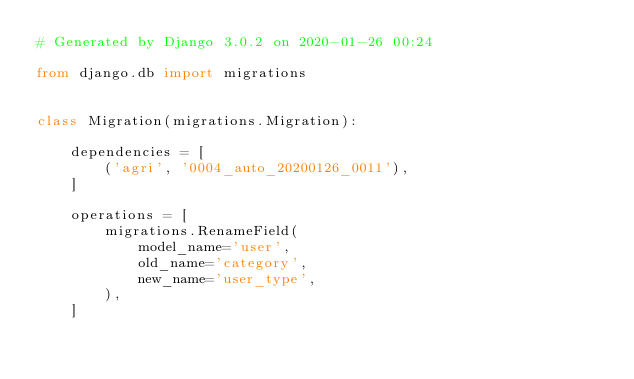Convert code to text. <code><loc_0><loc_0><loc_500><loc_500><_Python_># Generated by Django 3.0.2 on 2020-01-26 00:24

from django.db import migrations


class Migration(migrations.Migration):

    dependencies = [
        ('agri', '0004_auto_20200126_0011'),
    ]

    operations = [
        migrations.RenameField(
            model_name='user',
            old_name='category',
            new_name='user_type',
        ),
    ]
</code> 